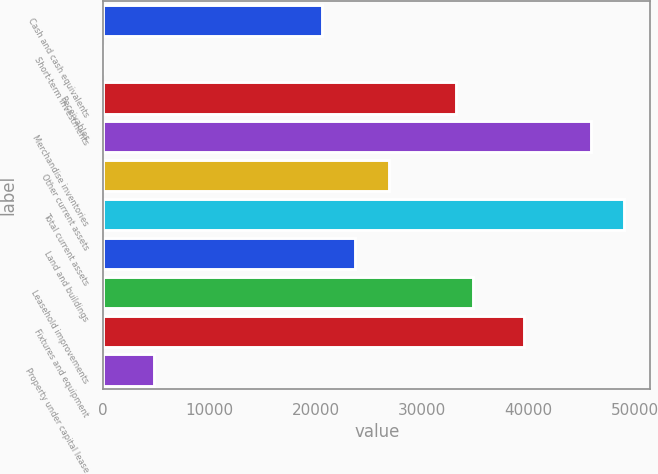Convert chart to OTSL. <chart><loc_0><loc_0><loc_500><loc_500><bar_chart><fcel>Cash and cash equivalents<fcel>Short-term investments<fcel>Receivables<fcel>Merchandise inventories<fcel>Other current assets<fcel>Total current assets<fcel>Land and buildings<fcel>Leasehold improvements<fcel>Fixtures and equipment<fcel>Property under capital lease<nl><fcel>20570.5<fcel>11<fcel>33222.5<fcel>45874.5<fcel>26896.5<fcel>49037.5<fcel>23733.5<fcel>34804<fcel>39548.5<fcel>4755.5<nl></chart> 